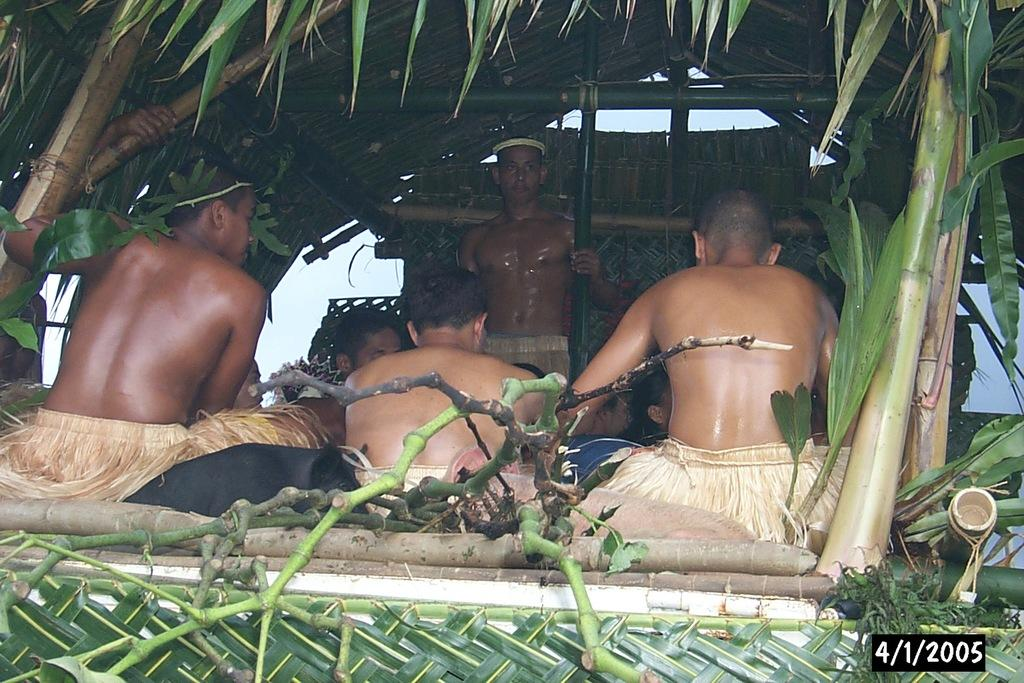What is the main setting of the image? There is a group of people in a hut in the image. What materials can be seen in the image? Bamboo sticks and branches are visible in the image. What is visible in the background of the image? The sky is visible in the image. Can you determine the time of day the image was taken? The image was likely taken during the day, as there is sufficient light to see the details. What type of memory is stored in the bamboo sticks in the image? There is no indication in the image that the bamboo sticks are used for storing memory. 